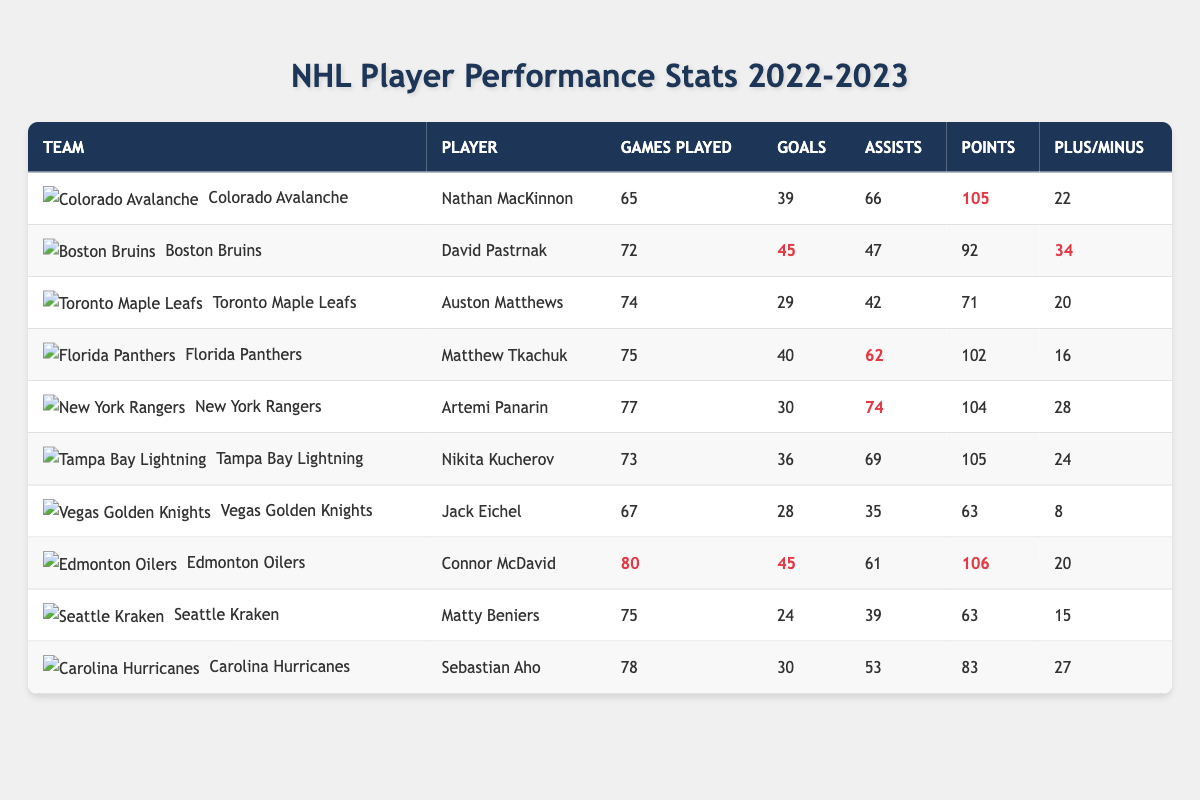What is the highest number of goals scored by a player listed in the table? By looking at the "Goals" column, the highest value is 45, which belongs to David Pastrnak of the Boston Bruins.
Answer: 45 Which player recorded the most points? The "Points" column shows Nathan MacKinnon and Connor McDavid both with 106 points. Thus, they are tied for the highest points.
Answer: Nathan MacKinnon and Connor McDavid How many assists did Sebastian Aho have? Looking in the "Assists" column next to Sebastian Aho in the table reveals that he had 53 assists.
Answer: 53 What is the average number of goals scored by players from the Colorado Avalanche and Boston Bruins? The goals scored by Nathan MacKinnon (39) and David Pastrnak (45) need to be summed: 39 + 45 = 84. Dividing by 2 gives an average of 42.
Answer: 42 Did any player have a plus/minus rating higher than 30? Checking the "Plus/Minus" column, David Pastrnak has a rating of 34, which exceeds 30.
Answer: Yes What are the total points for players from the Florida Panthers and New York Rangers? The points for Matthew Tkachuk (102) and Artemi Panarin (104) can be summed: 102 + 104 = 206.
Answer: 206 Which team did Connor McDavid play for? Directly observing the "Team" column next to Connor McDavid identifies the Edmonton Oilers.
Answer: Edmonton Oilers What is the difference in goals scored between Nathan MacKinnon and Auston Matthews? Nathan MacKinnon scored 39 goals and Auston Matthews scored 29 goals. The difference is 39 - 29 = 10.
Answer: 10 Is there a player with a below-zero plus/minus rating? Scanning through the "Plus/Minus" column, Jack Eichel has a plus/minus of 8, and all other players have positive values. Thus, there are no negative ratings.
Answer: No Who has more assists: Nikita Kucherov or Matthew Tkachuk? Nikita Kucherov has 69 assists and Matthew Tkachuk has 62 assists, so Kucherov has more.
Answer: Nikita Kucherov 